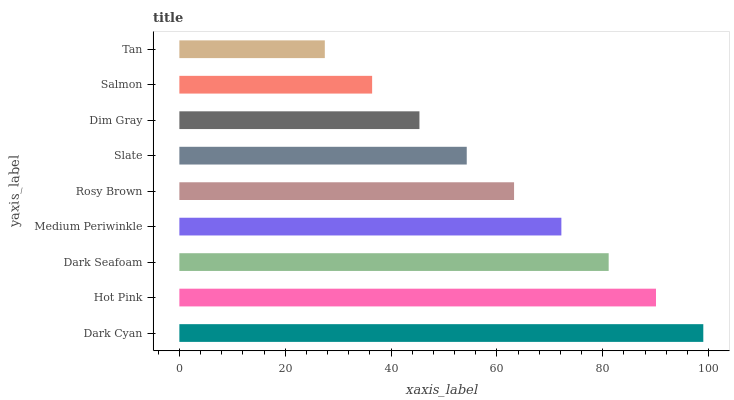Is Tan the minimum?
Answer yes or no. Yes. Is Dark Cyan the maximum?
Answer yes or no. Yes. Is Hot Pink the minimum?
Answer yes or no. No. Is Hot Pink the maximum?
Answer yes or no. No. Is Dark Cyan greater than Hot Pink?
Answer yes or no. Yes. Is Hot Pink less than Dark Cyan?
Answer yes or no. Yes. Is Hot Pink greater than Dark Cyan?
Answer yes or no. No. Is Dark Cyan less than Hot Pink?
Answer yes or no. No. Is Rosy Brown the high median?
Answer yes or no. Yes. Is Rosy Brown the low median?
Answer yes or no. Yes. Is Dark Seafoam the high median?
Answer yes or no. No. Is Dark Cyan the low median?
Answer yes or no. No. 